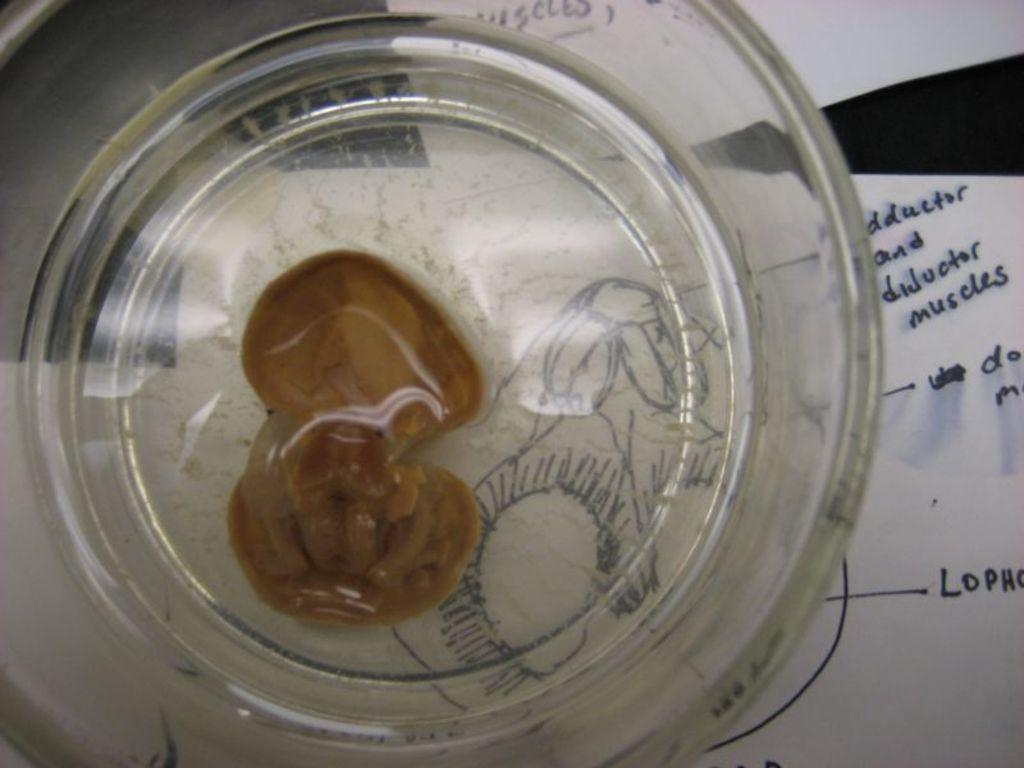What object is located inside the glass in the image? There is a shell in the image, and it is inside a glass. What can be seen in the background of the image? There are papers in the background of the image. Where are the papers located? The papers are on a table. What type of car is being advertised in the image? There is no car or advertisement present in the image; it only features a shell in a glass and papers in the background. 